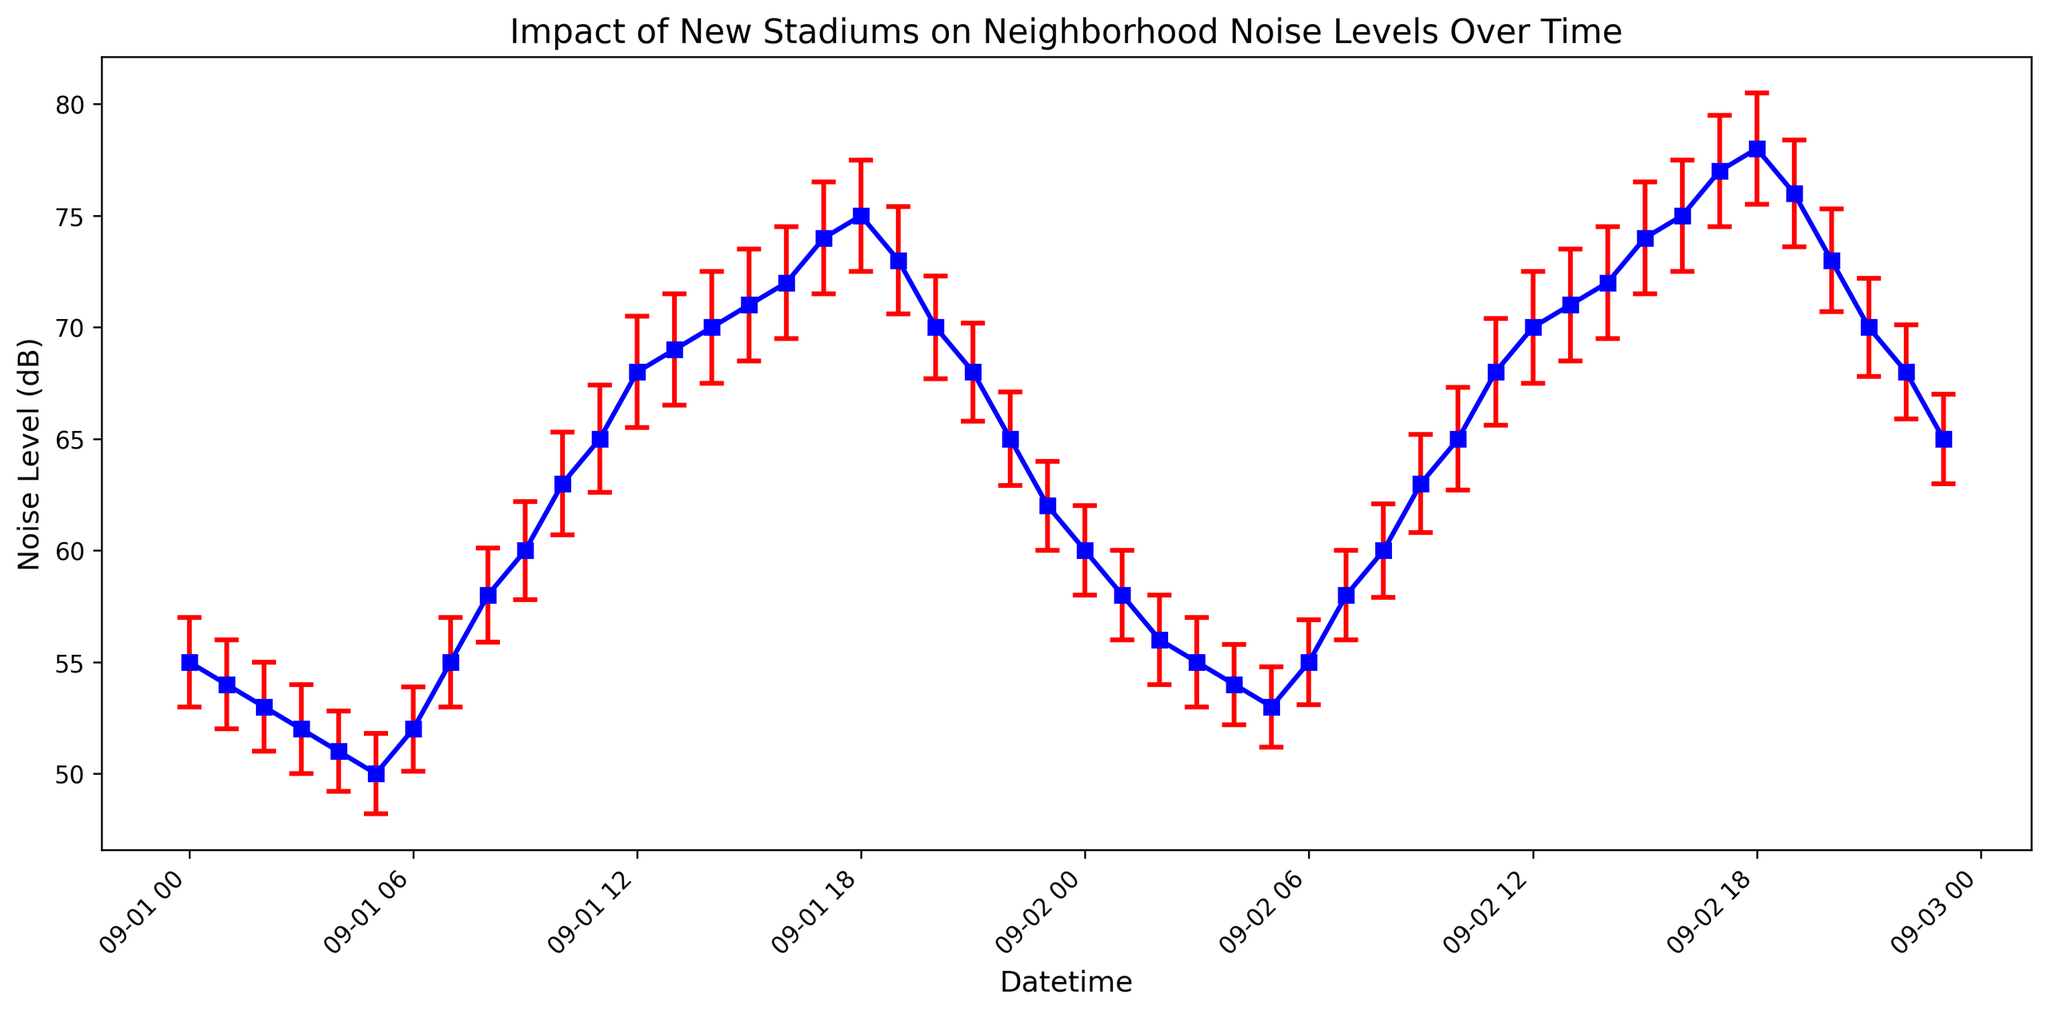What is the overall trend in noise levels over time from 00:00 to 23:00 on both days combined? To determine the overall trend in noise levels, we observe the plotted line. The noise level starts relatively low at midnight (around 55 dB), increases steadily during the day to reach a peak around 75 dB in the evening (between 17:00 and 18:00), and then decreases again at night.
Answer: Noise levels increase during the day and decrease at night How do the noise levels at midday (12:00) compare between the two days? To compare the noise levels at midday, we identify the data points at 12:00 on both days. On 2023-09-01, the noise level is 68 dB, and on 2023-09-02, it is 70 dB. We then compare these values.
Answer: Noise levels are slightly higher on the second day (70 dB) compared to the first day (68 dB) What is the average noise level between 08:00 and 12:00 on 2023-09-01? To find the average noise level, we calculate the mean of the noise levels from 08:00 to 12:00. (58 + 60 + 63 + 65 + 68) / 5 = 63.
Answer: 63 dB During which hour is the noise level highest on 2023-09-02? To determine the hour with the highest noise level, we look for the peak point on 2023-09-02. The highest value occurs at 18:00 with a noise level of 78 dB.
Answer: 18:00 What is the difference in noise levels between 03:00 and 15:00 on 2023-09-02? To find the difference, we subtract the noise level at 03:00 (55 dB) from the noise level at 15:00 (74 dB). 74 - 55 = 19.
Answer: 19 dB How do the error bars change from midnight to 06:00 on 2023-09-02? The error bars represent the standard error of the noise levels. From midnight (00:00) to 06:00, the error bars slightly decrease from 2 to 1.9 dB.
Answer: They slightly decrease At what times do noise levels exceed 70 dB on 2023-09-02? To find when noise levels exceed 70 dB, we look for points above this threshold. They occur at 14:00 - 20:00, and 18:00 marks the peak at 78 dB.
Answer: 14:00 to 20:00 Compare the error bars' visual attributes across the two days. Do they have the same color? To compare the visual attributes, we look at the color of the error bars. In the figure, error bars are red for both days.
Answer: Yes, they are both red What is the rate of increase in noise levels between 10:00 and 17:00 on 2023-09-01? To find the rate of increase, we calculate the difference in noise levels between 10:00 (63 dB) and 17:00 (74 dB). This difference is 11 dB over a 7-hour period, so the rate is 11 / 7 ≈ 1.57 dB per hour.
Answer: 1.57 dB per hour 